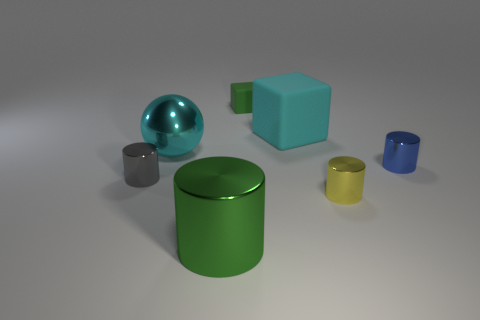How many small things are gray things or yellow objects? In the image, there is one small gray cylinder and one small yellow cup, making a total of two small items that are either gray or yellow. 